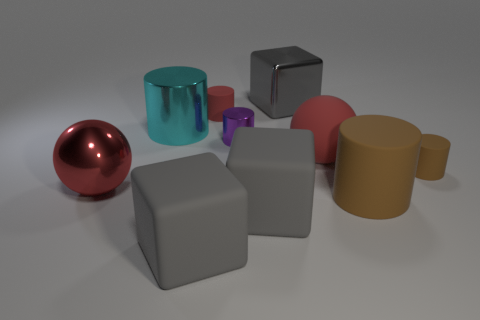There is a rubber ball; is its color the same as the large shiny object on the right side of the small metal thing?
Provide a short and direct response. No. There is a large red ball on the right side of the small shiny cylinder; what material is it?
Provide a succinct answer. Rubber. Are there any rubber things of the same color as the big rubber sphere?
Provide a short and direct response. Yes. What color is the rubber cylinder that is the same size as the cyan shiny cylinder?
Offer a very short reply. Brown. What number of big objects are purple cylinders or yellow matte cubes?
Provide a short and direct response. 0. Is the number of rubber objects that are to the left of the small brown cylinder the same as the number of large red matte spheres on the left side of the big cyan cylinder?
Offer a terse response. No. What number of red objects are the same size as the cyan cylinder?
Offer a very short reply. 2. What number of brown things are either rubber balls or metal cylinders?
Your answer should be compact. 0. Is the number of red spheres on the right side of the tiny brown rubber cylinder the same as the number of green cylinders?
Your answer should be very brief. Yes. There is a red rubber object to the left of the gray metal cube; what is its size?
Your answer should be very brief. Small. 